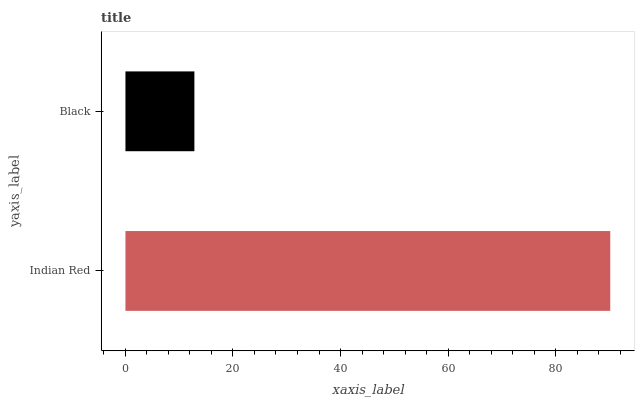Is Black the minimum?
Answer yes or no. Yes. Is Indian Red the maximum?
Answer yes or no. Yes. Is Black the maximum?
Answer yes or no. No. Is Indian Red greater than Black?
Answer yes or no. Yes. Is Black less than Indian Red?
Answer yes or no. Yes. Is Black greater than Indian Red?
Answer yes or no. No. Is Indian Red less than Black?
Answer yes or no. No. Is Indian Red the high median?
Answer yes or no. Yes. Is Black the low median?
Answer yes or no. Yes. Is Black the high median?
Answer yes or no. No. Is Indian Red the low median?
Answer yes or no. No. 